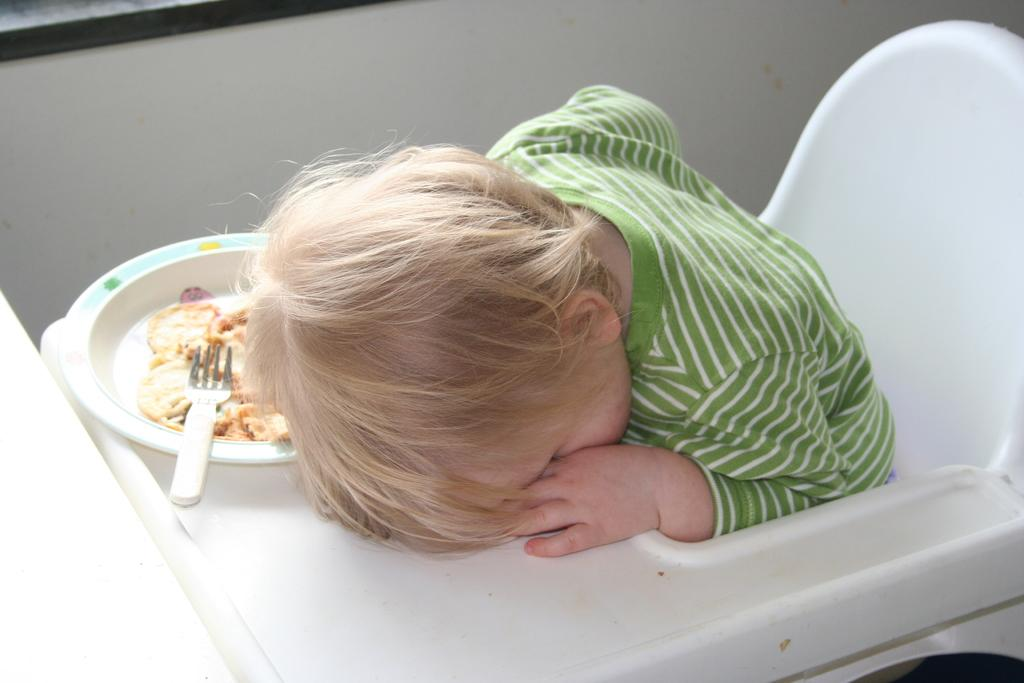What is the main subject of the image? There is an infant in the image. Where is the infant sitting? The infant is sitting in a white chair. What is on the plate in the image? The plate has a spoon on it, and there is food on the plate. What type of sound can be heard coming from the infant in the image? There is no sound present in the image, so it cannot be determined what, if any, sound might be heard. 